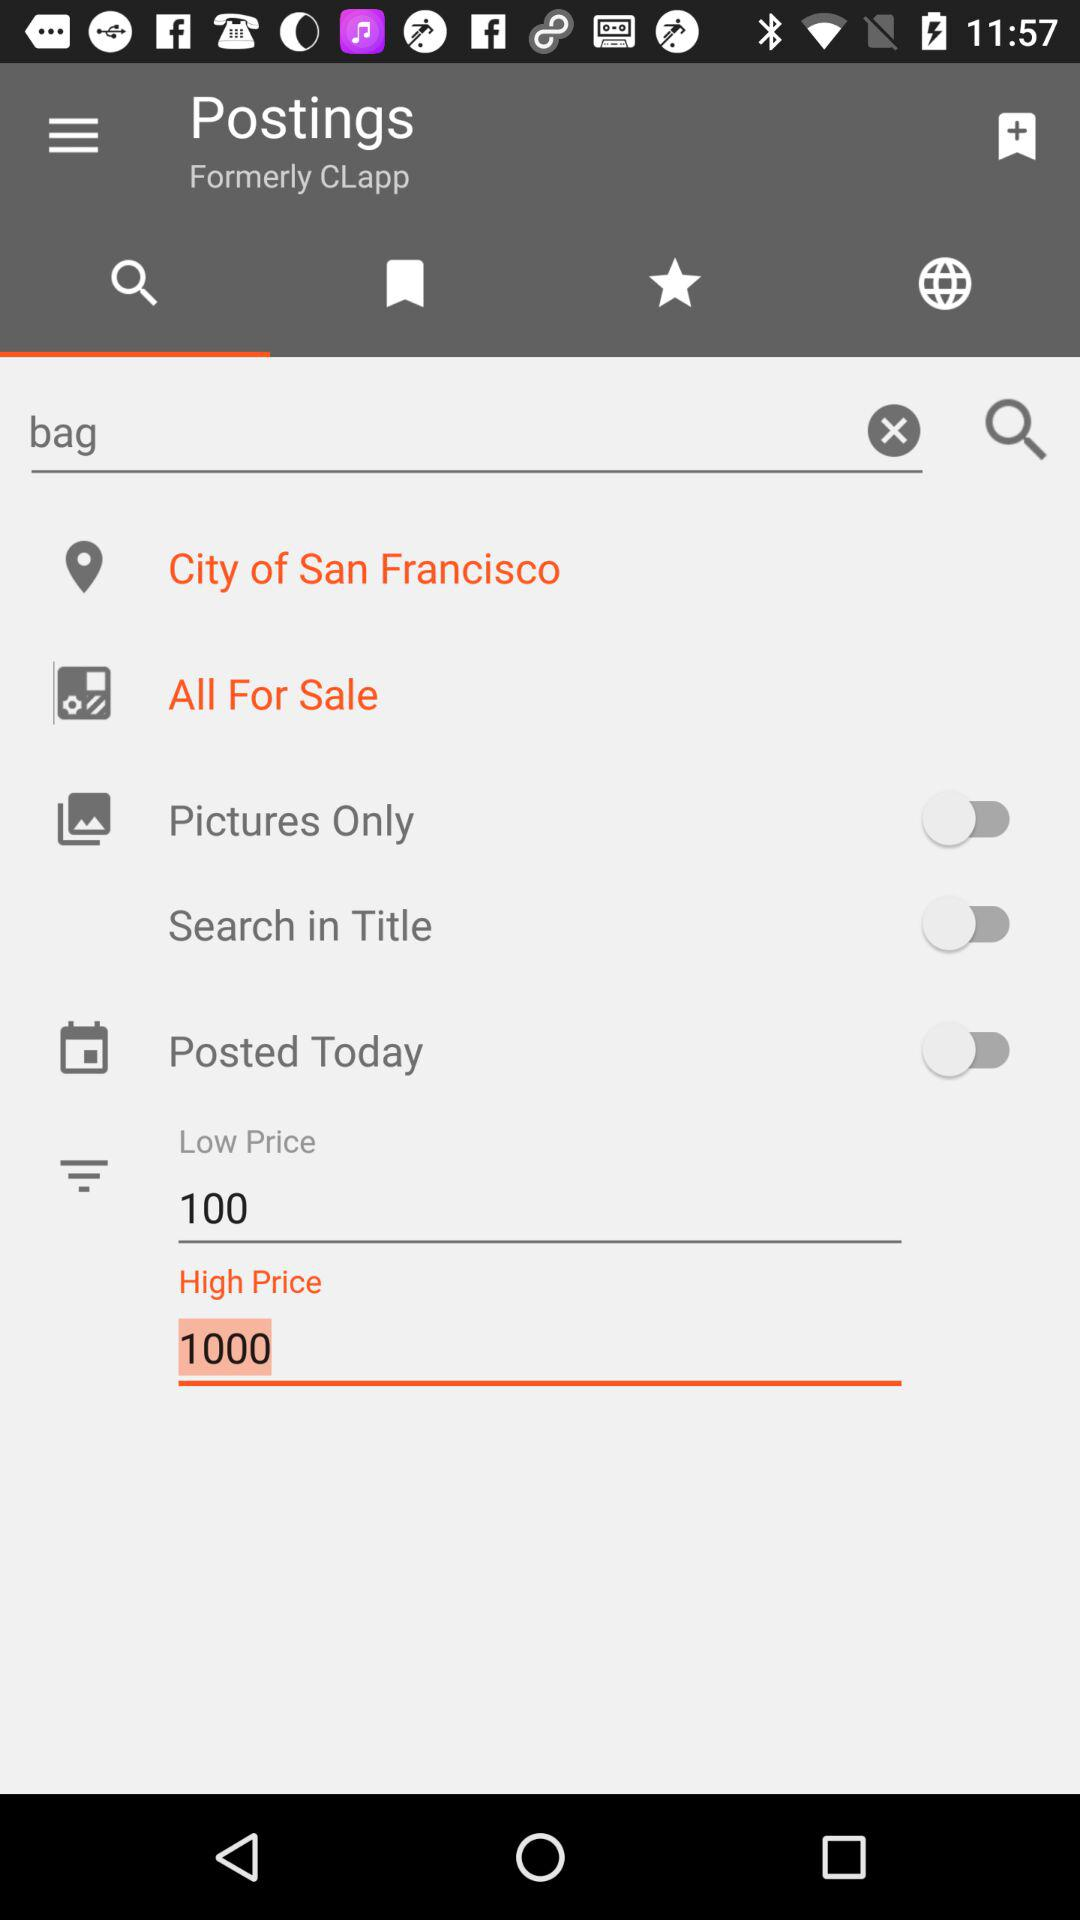What is the status of the "Posted Today"? The status is "off". 